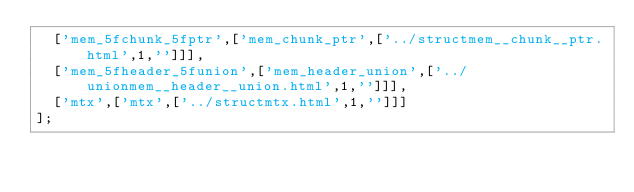Convert code to text. <code><loc_0><loc_0><loc_500><loc_500><_JavaScript_>  ['mem_5fchunk_5fptr',['mem_chunk_ptr',['../structmem__chunk__ptr.html',1,'']]],
  ['mem_5fheader_5funion',['mem_header_union',['../unionmem__header__union.html',1,'']]],
  ['mtx',['mtx',['../structmtx.html',1,'']]]
];
</code> 